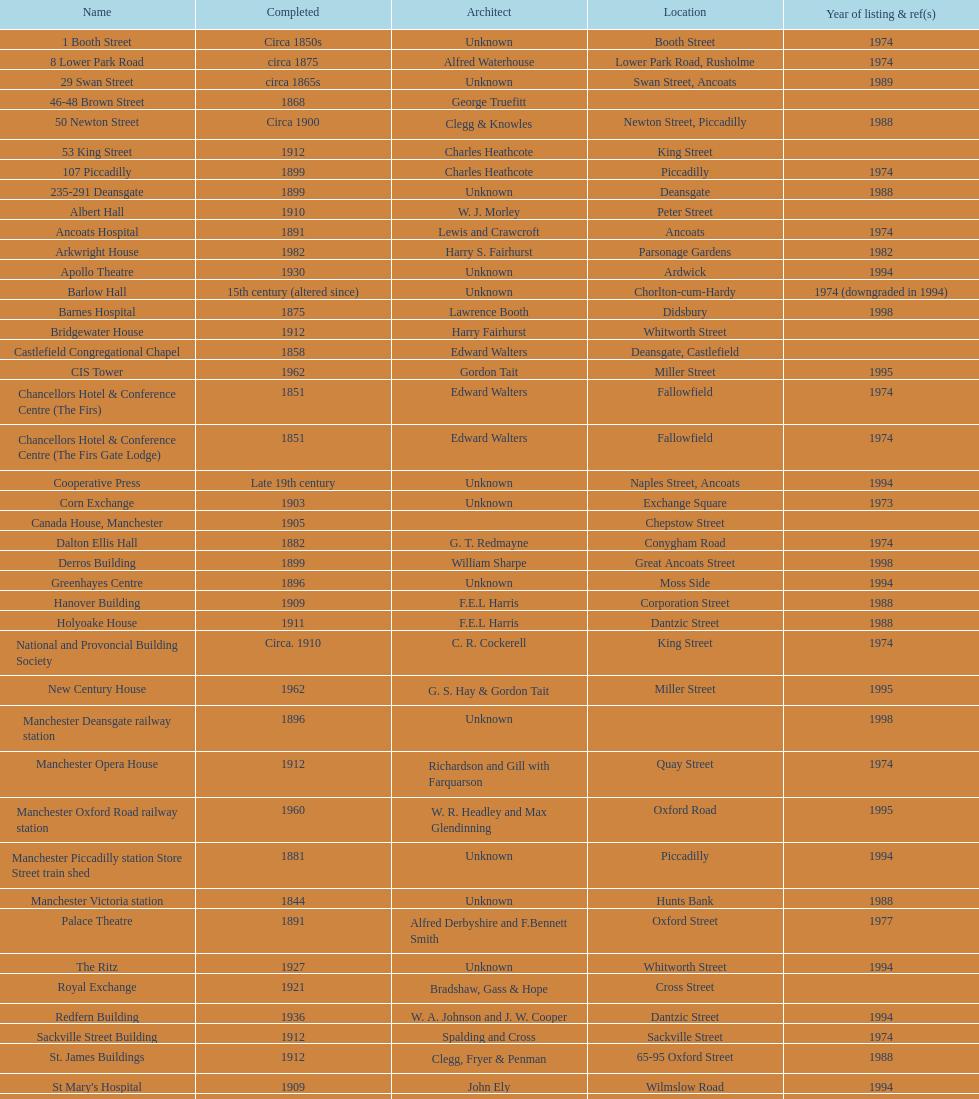In which year were the highest number of buildings registered? 1974. 